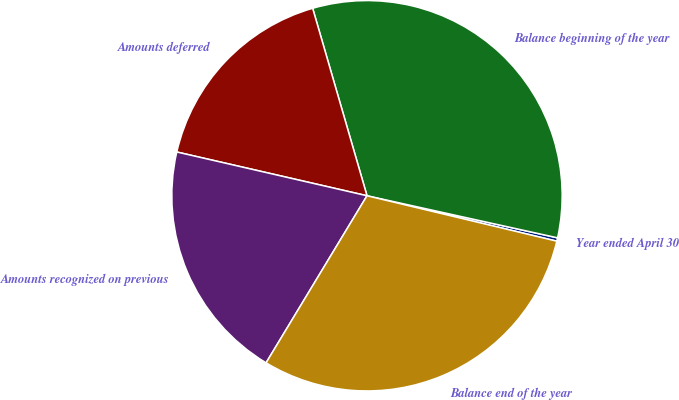Convert chart. <chart><loc_0><loc_0><loc_500><loc_500><pie_chart><fcel>Year ended April 30<fcel>Balance beginning of the year<fcel>Amounts deferred<fcel>Amounts recognized on previous<fcel>Balance end of the year<nl><fcel>0.28%<fcel>32.95%<fcel>16.91%<fcel>19.95%<fcel>29.91%<nl></chart> 